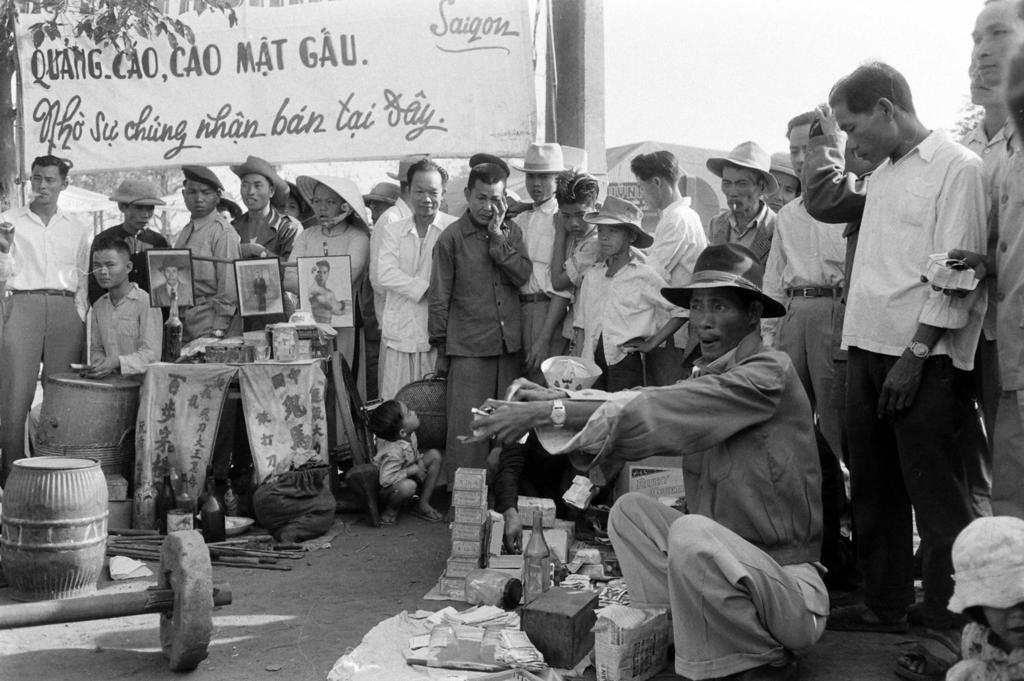Can you describe this image briefly? In the image we can see there are people sitting on the ground and there are other people standing. Few people are wearing hats and they are holding photo frames in their hand. There are bottles, boxes, papers and stone weightlifter kept on the ground. Behind there is a hoarding and the image is in black and white colour. 